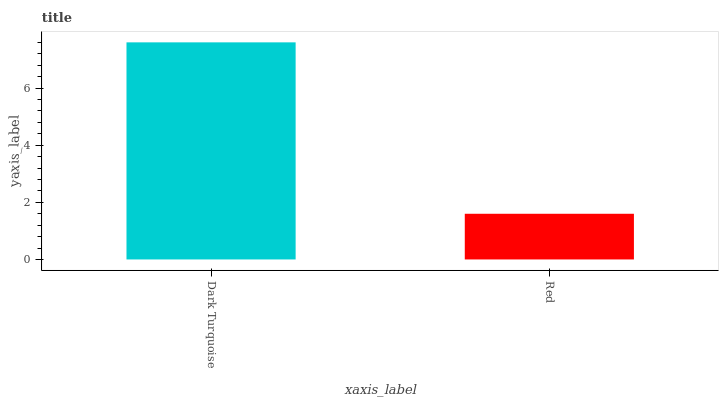Is Red the maximum?
Answer yes or no. No. Is Dark Turquoise greater than Red?
Answer yes or no. Yes. Is Red less than Dark Turquoise?
Answer yes or no. Yes. Is Red greater than Dark Turquoise?
Answer yes or no. No. Is Dark Turquoise less than Red?
Answer yes or no. No. Is Dark Turquoise the high median?
Answer yes or no. Yes. Is Red the low median?
Answer yes or no. Yes. Is Red the high median?
Answer yes or no. No. Is Dark Turquoise the low median?
Answer yes or no. No. 